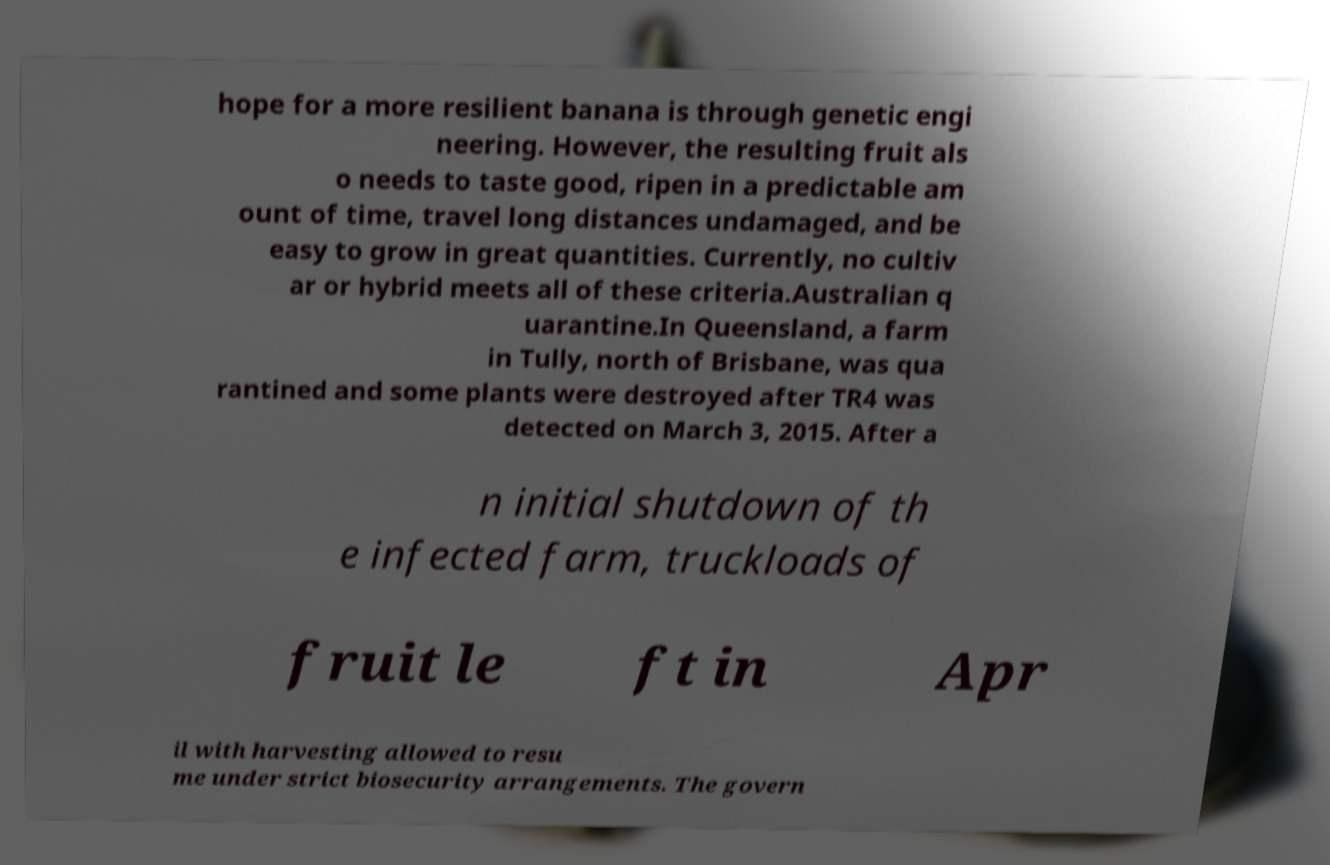What messages or text are displayed in this image? I need them in a readable, typed format. hope for a more resilient banana is through genetic engi neering. However, the resulting fruit als o needs to taste good, ripen in a predictable am ount of time, travel long distances undamaged, and be easy to grow in great quantities. Currently, no cultiv ar or hybrid meets all of these criteria.Australian q uarantine.In Queensland, a farm in Tully, north of Brisbane, was qua rantined and some plants were destroyed after TR4 was detected on March 3, 2015. After a n initial shutdown of th e infected farm, truckloads of fruit le ft in Apr il with harvesting allowed to resu me under strict biosecurity arrangements. The govern 